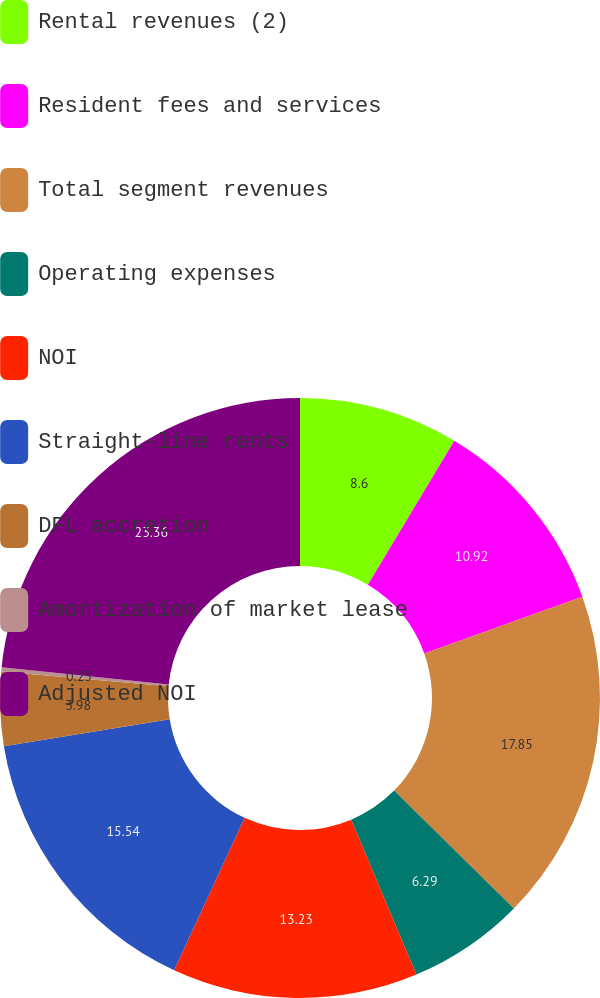<chart> <loc_0><loc_0><loc_500><loc_500><pie_chart><fcel>Rental revenues (2)<fcel>Resident fees and services<fcel>Total segment revenues<fcel>Operating expenses<fcel>NOI<fcel>Straight-line rents<fcel>DFL accretion<fcel>Amortization of market lease<fcel>Adjusted NOI<nl><fcel>8.6%<fcel>10.92%<fcel>17.85%<fcel>6.29%<fcel>13.23%<fcel>15.54%<fcel>3.98%<fcel>0.23%<fcel>23.36%<nl></chart> 